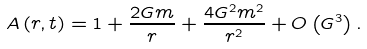Convert formula to latex. <formula><loc_0><loc_0><loc_500><loc_500>A \left ( r , t \right ) = 1 + \frac { 2 G m } { r } + \frac { 4 G ^ { 2 } m ^ { 2 } } { r ^ { 2 } } + O \left ( G ^ { 3 } \right ) .</formula> 